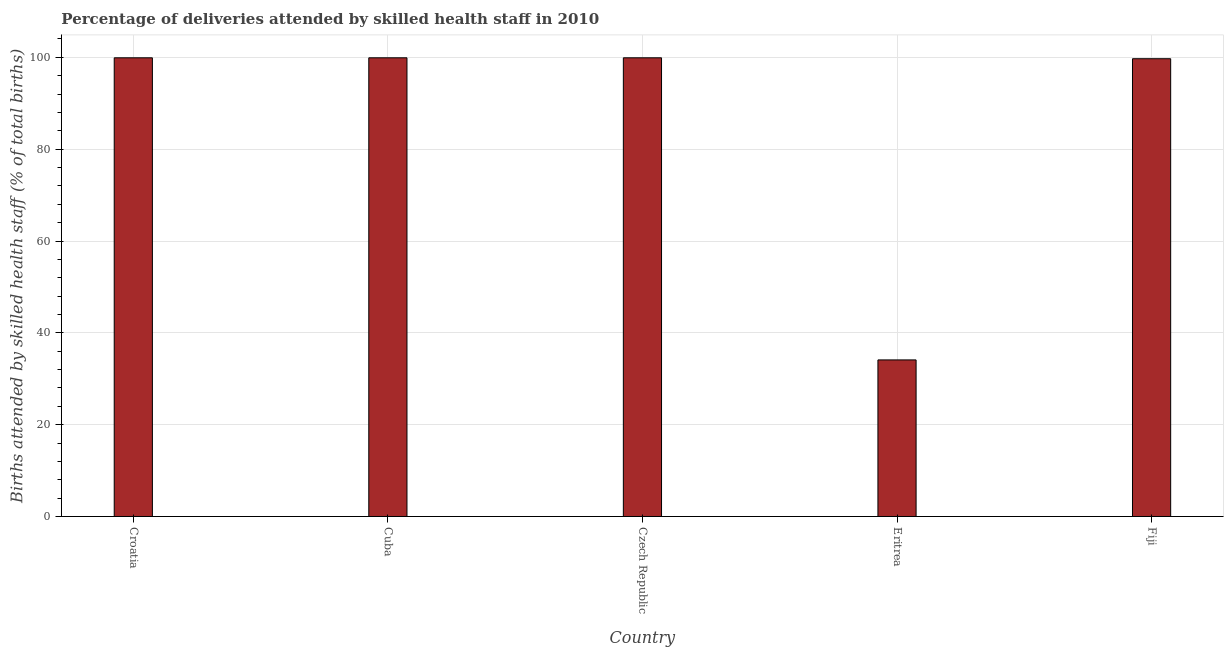Does the graph contain any zero values?
Offer a terse response. No. What is the title of the graph?
Your answer should be compact. Percentage of deliveries attended by skilled health staff in 2010. What is the label or title of the X-axis?
Your answer should be compact. Country. What is the label or title of the Y-axis?
Your response must be concise. Births attended by skilled health staff (% of total births). What is the number of births attended by skilled health staff in Eritrea?
Offer a terse response. 34.1. Across all countries, what is the maximum number of births attended by skilled health staff?
Give a very brief answer. 99.9. Across all countries, what is the minimum number of births attended by skilled health staff?
Give a very brief answer. 34.1. In which country was the number of births attended by skilled health staff maximum?
Make the answer very short. Croatia. In which country was the number of births attended by skilled health staff minimum?
Provide a short and direct response. Eritrea. What is the sum of the number of births attended by skilled health staff?
Ensure brevity in your answer.  433.5. What is the difference between the number of births attended by skilled health staff in Eritrea and Fiji?
Keep it short and to the point. -65.6. What is the average number of births attended by skilled health staff per country?
Provide a succinct answer. 86.7. What is the median number of births attended by skilled health staff?
Provide a succinct answer. 99.9. In how many countries, is the number of births attended by skilled health staff greater than 80 %?
Provide a short and direct response. 4. What is the ratio of the number of births attended by skilled health staff in Croatia to that in Fiji?
Your answer should be very brief. 1. Is the number of births attended by skilled health staff in Croatia less than that in Eritrea?
Offer a terse response. No. Is the difference between the number of births attended by skilled health staff in Czech Republic and Eritrea greater than the difference between any two countries?
Offer a very short reply. Yes. What is the difference between the highest and the lowest number of births attended by skilled health staff?
Provide a short and direct response. 65.8. Are all the bars in the graph horizontal?
Your answer should be very brief. No. How many countries are there in the graph?
Provide a succinct answer. 5. What is the difference between two consecutive major ticks on the Y-axis?
Ensure brevity in your answer.  20. What is the Births attended by skilled health staff (% of total births) in Croatia?
Your answer should be very brief. 99.9. What is the Births attended by skilled health staff (% of total births) of Cuba?
Your response must be concise. 99.9. What is the Births attended by skilled health staff (% of total births) in Czech Republic?
Your answer should be very brief. 99.9. What is the Births attended by skilled health staff (% of total births) of Eritrea?
Keep it short and to the point. 34.1. What is the Births attended by skilled health staff (% of total births) in Fiji?
Ensure brevity in your answer.  99.7. What is the difference between the Births attended by skilled health staff (% of total births) in Croatia and Eritrea?
Keep it short and to the point. 65.8. What is the difference between the Births attended by skilled health staff (% of total births) in Cuba and Eritrea?
Provide a short and direct response. 65.8. What is the difference between the Births attended by skilled health staff (% of total births) in Cuba and Fiji?
Provide a succinct answer. 0.2. What is the difference between the Births attended by skilled health staff (% of total births) in Czech Republic and Eritrea?
Your answer should be very brief. 65.8. What is the difference between the Births attended by skilled health staff (% of total births) in Czech Republic and Fiji?
Keep it short and to the point. 0.2. What is the difference between the Births attended by skilled health staff (% of total births) in Eritrea and Fiji?
Provide a succinct answer. -65.6. What is the ratio of the Births attended by skilled health staff (% of total births) in Croatia to that in Cuba?
Your answer should be compact. 1. What is the ratio of the Births attended by skilled health staff (% of total births) in Croatia to that in Eritrea?
Keep it short and to the point. 2.93. What is the ratio of the Births attended by skilled health staff (% of total births) in Cuba to that in Eritrea?
Give a very brief answer. 2.93. What is the ratio of the Births attended by skilled health staff (% of total births) in Czech Republic to that in Eritrea?
Provide a short and direct response. 2.93. What is the ratio of the Births attended by skilled health staff (% of total births) in Eritrea to that in Fiji?
Give a very brief answer. 0.34. 